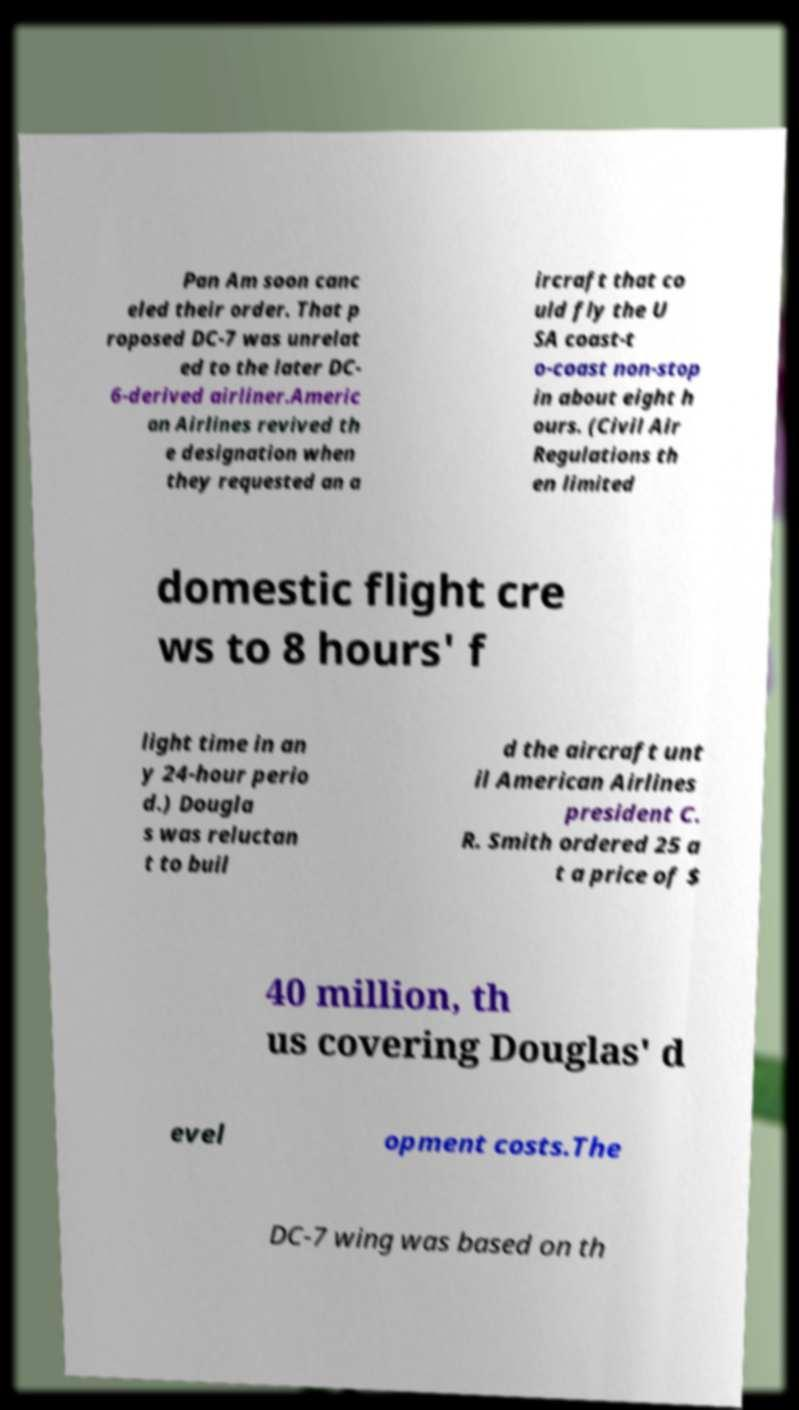Please read and relay the text visible in this image. What does it say? Pan Am soon canc eled their order. That p roposed DC-7 was unrelat ed to the later DC- 6-derived airliner.Americ an Airlines revived th e designation when they requested an a ircraft that co uld fly the U SA coast-t o-coast non-stop in about eight h ours. (Civil Air Regulations th en limited domestic flight cre ws to 8 hours' f light time in an y 24-hour perio d.) Dougla s was reluctan t to buil d the aircraft unt il American Airlines president C. R. Smith ordered 25 a t a price of $ 40 million, th us covering Douglas' d evel opment costs.The DC-7 wing was based on th 